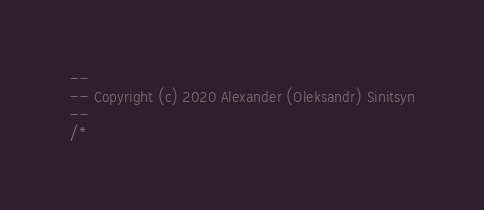Convert code to text. <code><loc_0><loc_0><loc_500><loc_500><_SQL_>--
-- Copyright (c) 2020 Alexander (Oleksandr) Sinitsyn
--
/*</code> 